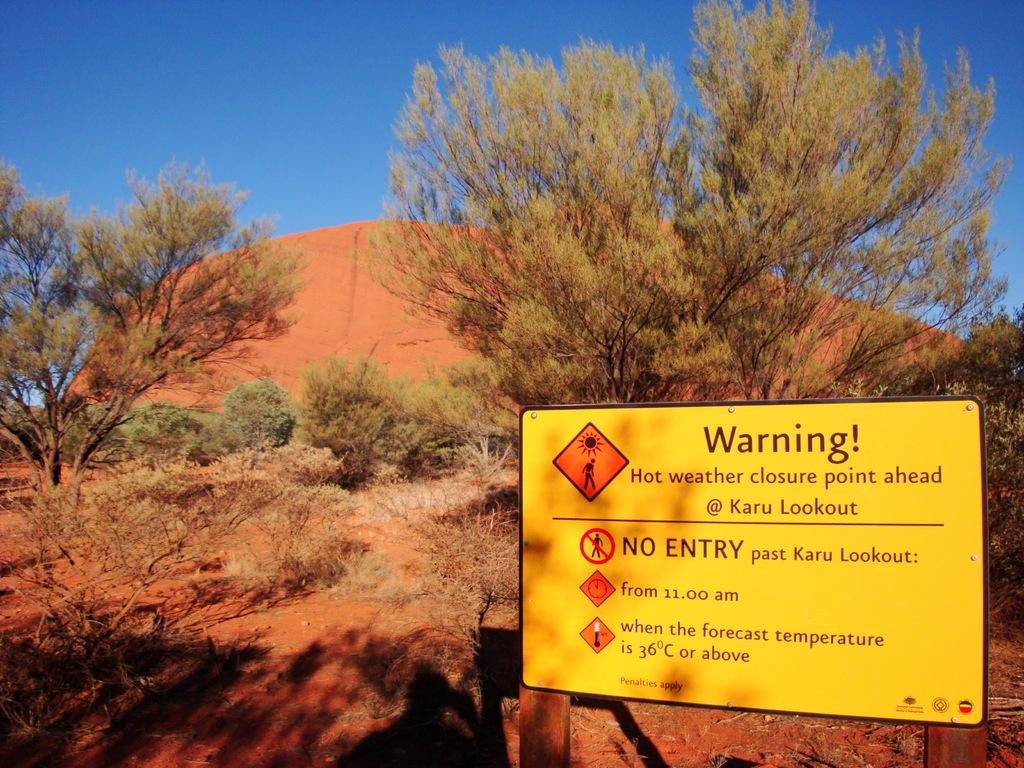What type of natural elements can be seen on the ground in the image? There are trees and plants on the ground in the image. What is the color of the board that is visible in the image? The board in the image is yellow. What is written or displayed on the yellow color board? Something is written on the yellow color board. What can be seen in the background of the image? The sky is visible in the background of the image. Can you describe the pancake being flipped in the image? There is no pancake present in the image, so it cannot be described. What type of driving is taking place in the image? There is no driving activity depicted in the image. 